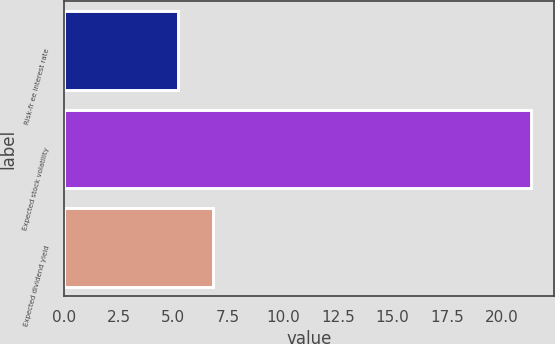<chart> <loc_0><loc_0><loc_500><loc_500><bar_chart><fcel>Risk-fr ee interest rate<fcel>Expected stock volatility<fcel>Expected dividend yield<nl><fcel>5.22<fcel>21.32<fcel>6.83<nl></chart> 